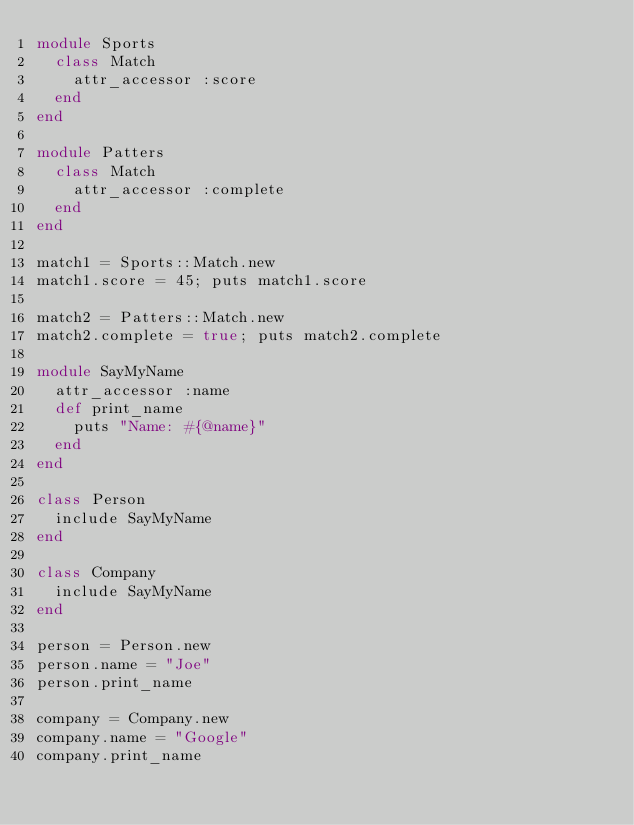Convert code to text. <code><loc_0><loc_0><loc_500><loc_500><_Ruby_>module Sports
  class Match
    attr_accessor :score
  end
end

module Patters
  class Match
    attr_accessor :complete
  end
end

match1 = Sports::Match.new
match1.score = 45; puts match1.score

match2 = Patters::Match.new
match2.complete = true; puts match2.complete

module SayMyName
  attr_accessor :name
  def print_name
    puts "Name: #{@name}"
  end
end

class Person
  include SayMyName
end

class Company
  include SayMyName
end

person = Person.new
person.name = "Joe"
person.print_name

company = Company.new
company.name = "Google"
company.print_name
</code> 